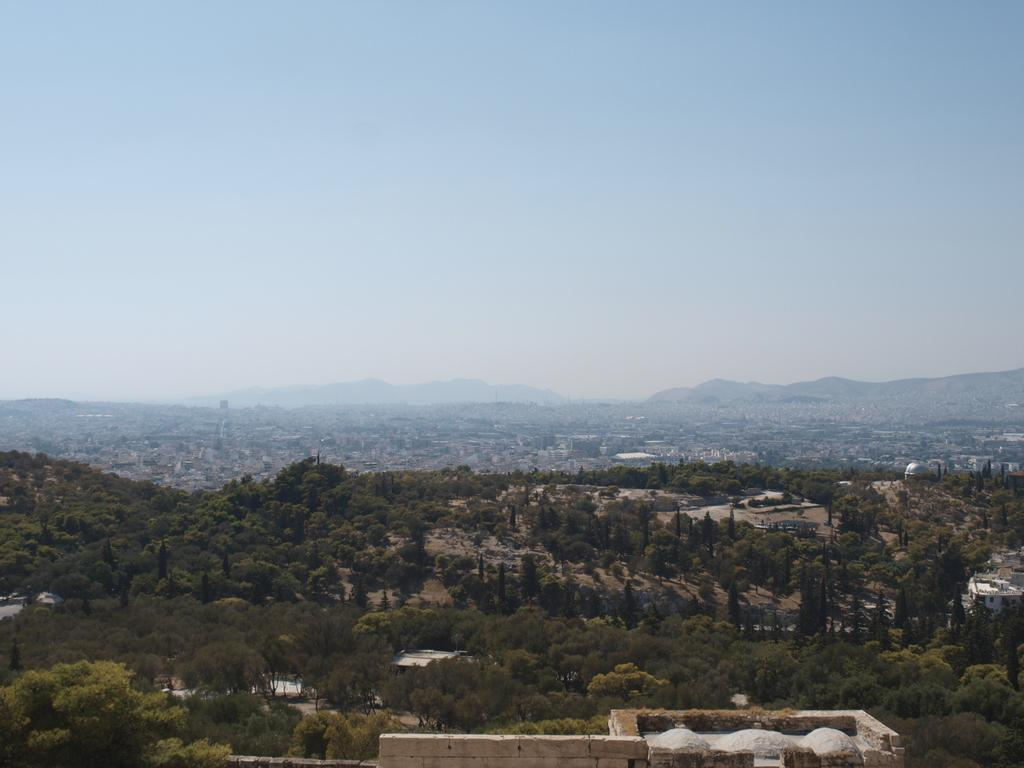Where was the image taken? The image was clicked outside the city. What can be seen in the foreground of the image? There are buildings and trees in the foreground of the image. What can be seen in the background of the image? There are buildings in the background of the image. What is visible in the background of the image? The sky is visible in the background of the image. What type of chin is visible on the tree in the image? There is no chin present in the image, as it features buildings and trees in an outdoor setting. 